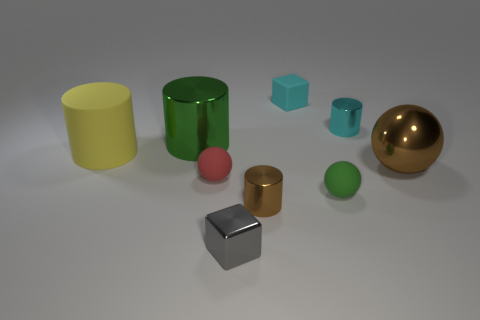What is the color of the matte object that is right of the yellow matte cylinder and on the left side of the brown cylinder?
Offer a very short reply. Red. How many spheres are either tiny gray metallic things or large green objects?
Give a very brief answer. 0. Are there fewer big rubber cylinders behind the large rubber cylinder than blue metal cylinders?
Your answer should be very brief. No. The tiny cyan thing that is the same material as the small brown cylinder is what shape?
Provide a succinct answer. Cylinder. What number of shiny cylinders have the same color as the big ball?
Your answer should be very brief. 1. What number of objects are cylinders or cyan shiny blocks?
Your answer should be compact. 4. What material is the green thing that is on the right side of the matte ball that is left of the green rubber object made of?
Provide a short and direct response. Rubber. Is there another thing that has the same material as the red thing?
Provide a short and direct response. Yes. There is a tiny thing to the left of the small metallic object that is left of the cylinder that is in front of the large brown shiny object; what is its shape?
Ensure brevity in your answer.  Sphere. What is the cyan cylinder made of?
Make the answer very short. Metal. 